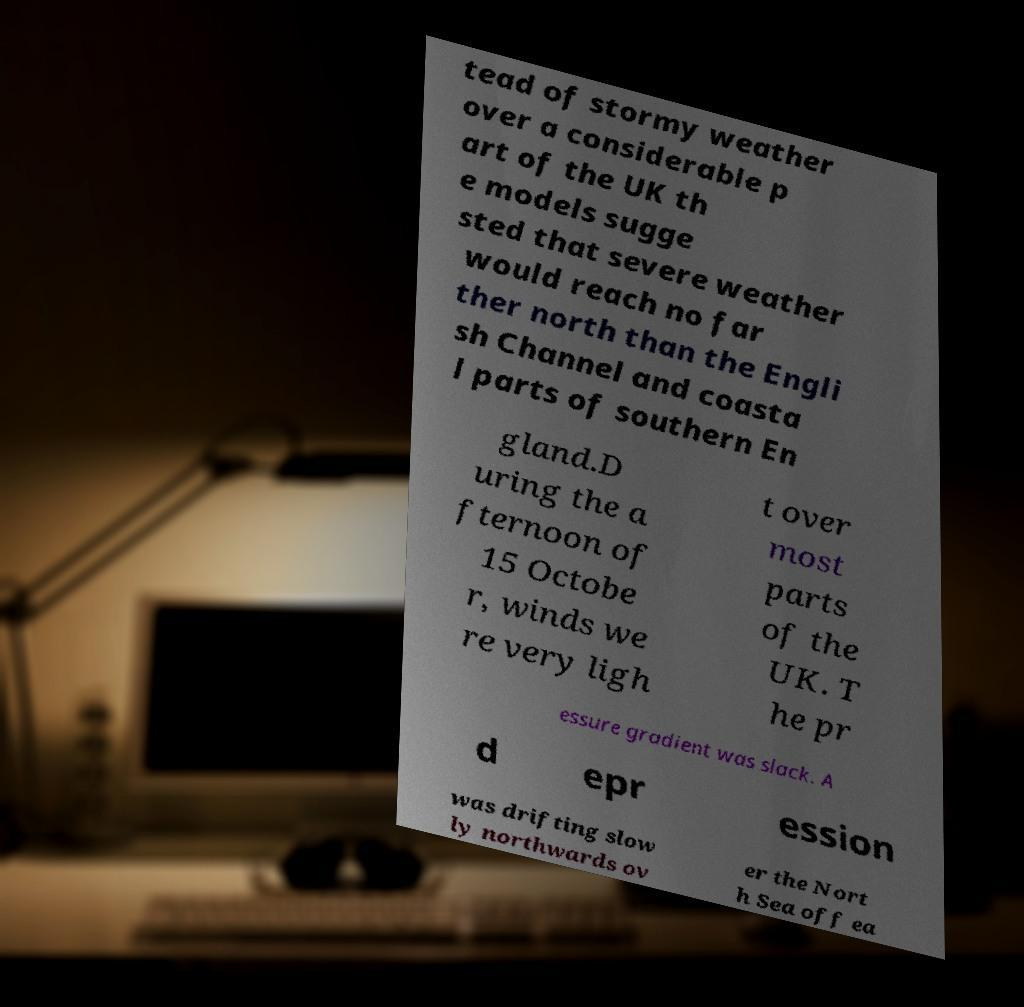Can you read and provide the text displayed in the image?This photo seems to have some interesting text. Can you extract and type it out for me? tead of stormy weather over a considerable p art of the UK th e models sugge sted that severe weather would reach no far ther north than the Engli sh Channel and coasta l parts of southern En gland.D uring the a fternoon of 15 Octobe r, winds we re very ligh t over most parts of the UK. T he pr essure gradient was slack. A d epr ession was drifting slow ly northwards ov er the Nort h Sea off ea 